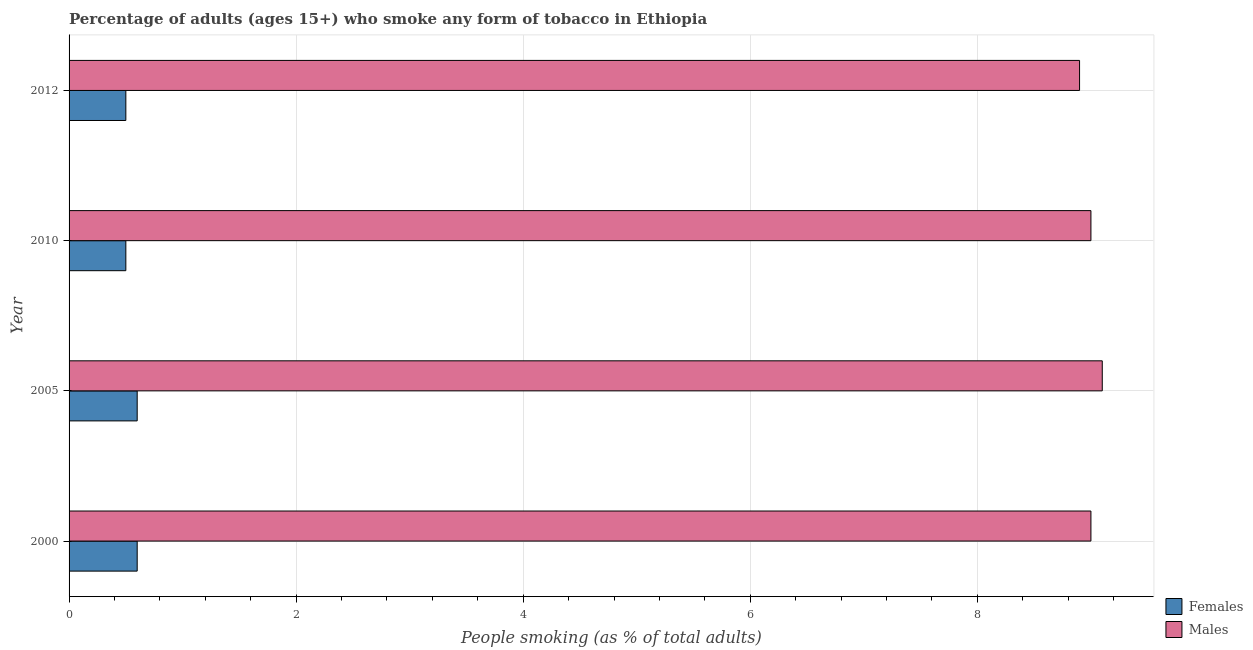Are the number of bars per tick equal to the number of legend labels?
Provide a short and direct response. Yes. What is the label of the 2nd group of bars from the top?
Your answer should be compact. 2010. What is the percentage of females who smoke in 2005?
Keep it short and to the point. 0.6. Across all years, what is the maximum percentage of females who smoke?
Provide a short and direct response. 0.6. In which year was the percentage of males who smoke maximum?
Provide a succinct answer. 2005. What is the total percentage of males who smoke in the graph?
Make the answer very short. 36. What is the difference between the percentage of females who smoke in 2010 and that in 2012?
Make the answer very short. 0. What is the difference between the percentage of males who smoke in 2005 and the percentage of females who smoke in 2012?
Ensure brevity in your answer.  8.6. What is the average percentage of females who smoke per year?
Give a very brief answer. 0.55. In how many years, is the percentage of females who smoke greater than 6.8 %?
Your answer should be compact. 0. What is the ratio of the percentage of females who smoke in 2005 to that in 2010?
Give a very brief answer. 1.2. Is the difference between the percentage of males who smoke in 2005 and 2010 greater than the difference between the percentage of females who smoke in 2005 and 2010?
Your answer should be compact. No. In how many years, is the percentage of males who smoke greater than the average percentage of males who smoke taken over all years?
Offer a terse response. 1. Is the sum of the percentage of females who smoke in 2000 and 2012 greater than the maximum percentage of males who smoke across all years?
Keep it short and to the point. No. What does the 1st bar from the top in 2012 represents?
Your answer should be compact. Males. What does the 1st bar from the bottom in 2010 represents?
Provide a succinct answer. Females. How many bars are there?
Make the answer very short. 8. How many years are there in the graph?
Make the answer very short. 4. Are the values on the major ticks of X-axis written in scientific E-notation?
Your answer should be compact. No. Does the graph contain any zero values?
Provide a succinct answer. No. How are the legend labels stacked?
Offer a terse response. Vertical. What is the title of the graph?
Offer a terse response. Percentage of adults (ages 15+) who smoke any form of tobacco in Ethiopia. Does "GDP at market prices" appear as one of the legend labels in the graph?
Give a very brief answer. No. What is the label or title of the X-axis?
Offer a very short reply. People smoking (as % of total adults). What is the People smoking (as % of total adults) in Males in 2000?
Give a very brief answer. 9. What is the People smoking (as % of total adults) of Females in 2005?
Offer a very short reply. 0.6. What is the People smoking (as % of total adults) of Males in 2010?
Provide a short and direct response. 9. Across all years, what is the maximum People smoking (as % of total adults) in Females?
Your answer should be very brief. 0.6. Across all years, what is the minimum People smoking (as % of total adults) of Females?
Make the answer very short. 0.5. Across all years, what is the minimum People smoking (as % of total adults) of Males?
Your answer should be compact. 8.9. What is the difference between the People smoking (as % of total adults) of Females in 2000 and that in 2005?
Make the answer very short. 0. What is the difference between the People smoking (as % of total adults) in Males in 2000 and that in 2005?
Offer a terse response. -0.1. What is the difference between the People smoking (as % of total adults) of Males in 2000 and that in 2010?
Your answer should be very brief. 0. What is the difference between the People smoking (as % of total adults) of Females in 2000 and that in 2012?
Provide a short and direct response. 0.1. What is the difference between the People smoking (as % of total adults) of Females in 2005 and that in 2012?
Your answer should be very brief. 0.1. What is the difference between the People smoking (as % of total adults) in Males in 2005 and that in 2012?
Offer a very short reply. 0.2. What is the difference between the People smoking (as % of total adults) in Females in 2010 and that in 2012?
Ensure brevity in your answer.  0. What is the difference between the People smoking (as % of total adults) in Females in 2000 and the People smoking (as % of total adults) in Males in 2005?
Ensure brevity in your answer.  -8.5. What is the difference between the People smoking (as % of total adults) of Females in 2000 and the People smoking (as % of total adults) of Males in 2012?
Provide a succinct answer. -8.3. What is the difference between the People smoking (as % of total adults) in Females in 2005 and the People smoking (as % of total adults) in Males in 2010?
Make the answer very short. -8.4. What is the average People smoking (as % of total adults) of Females per year?
Provide a succinct answer. 0.55. In the year 2000, what is the difference between the People smoking (as % of total adults) in Females and People smoking (as % of total adults) in Males?
Your answer should be compact. -8.4. In the year 2005, what is the difference between the People smoking (as % of total adults) in Females and People smoking (as % of total adults) in Males?
Your answer should be very brief. -8.5. In the year 2010, what is the difference between the People smoking (as % of total adults) in Females and People smoking (as % of total adults) in Males?
Keep it short and to the point. -8.5. What is the ratio of the People smoking (as % of total adults) in Females in 2000 to that in 2010?
Offer a terse response. 1.2. What is the ratio of the People smoking (as % of total adults) in Males in 2000 to that in 2010?
Your response must be concise. 1. What is the ratio of the People smoking (as % of total adults) in Females in 2000 to that in 2012?
Offer a terse response. 1.2. What is the ratio of the People smoking (as % of total adults) in Males in 2000 to that in 2012?
Offer a terse response. 1.01. What is the ratio of the People smoking (as % of total adults) in Females in 2005 to that in 2010?
Offer a very short reply. 1.2. What is the ratio of the People smoking (as % of total adults) in Males in 2005 to that in 2010?
Give a very brief answer. 1.01. What is the ratio of the People smoking (as % of total adults) in Males in 2005 to that in 2012?
Offer a very short reply. 1.02. What is the ratio of the People smoking (as % of total adults) of Males in 2010 to that in 2012?
Provide a succinct answer. 1.01. 